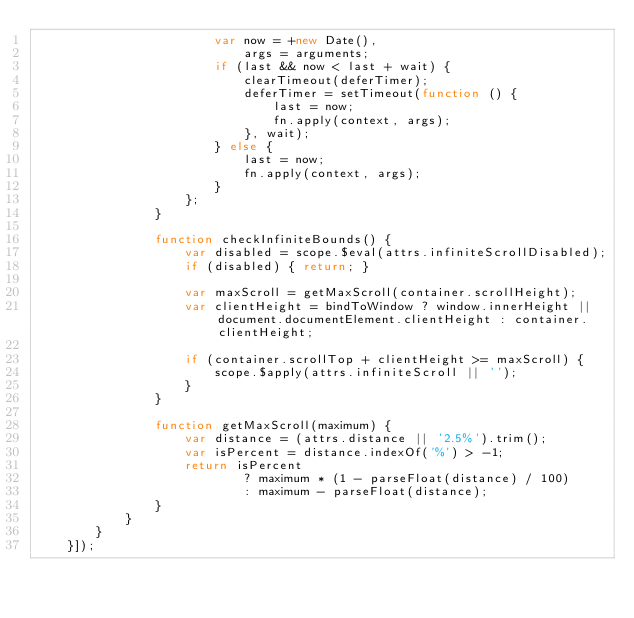<code> <loc_0><loc_0><loc_500><loc_500><_JavaScript_>                        var now = +new Date(),
                            args = arguments;
                        if (last && now < last + wait) {
                            clearTimeout(deferTimer);
                            deferTimer = setTimeout(function () {
                                last = now;
                                fn.apply(context, args);
                            }, wait);
                        } else {
                            last = now;
                            fn.apply(context, args);
                        }
                    };
                }
    
                function checkInfiniteBounds() {
                    var disabled = scope.$eval(attrs.infiniteScrollDisabled);
                    if (disabled) { return; }
                    
                    var maxScroll = getMaxScroll(container.scrollHeight);
                    var clientHeight = bindToWindow ? window.innerHeight || document.documentElement.clientHeight : container.clientHeight;
                    
                    if (container.scrollTop + clientHeight >= maxScroll) {
                        scope.$apply(attrs.infiniteScroll || '');
                    }
                }
    
                function getMaxScroll(maximum) {
                    var distance = (attrs.distance || '2.5%').trim();
                    var isPercent = distance.indexOf('%') > -1;
                    return isPercent
                            ? maximum * (1 - parseFloat(distance) / 100)
                            : maximum - parseFloat(distance);
                }
            }
        }
    }]);
</code> 